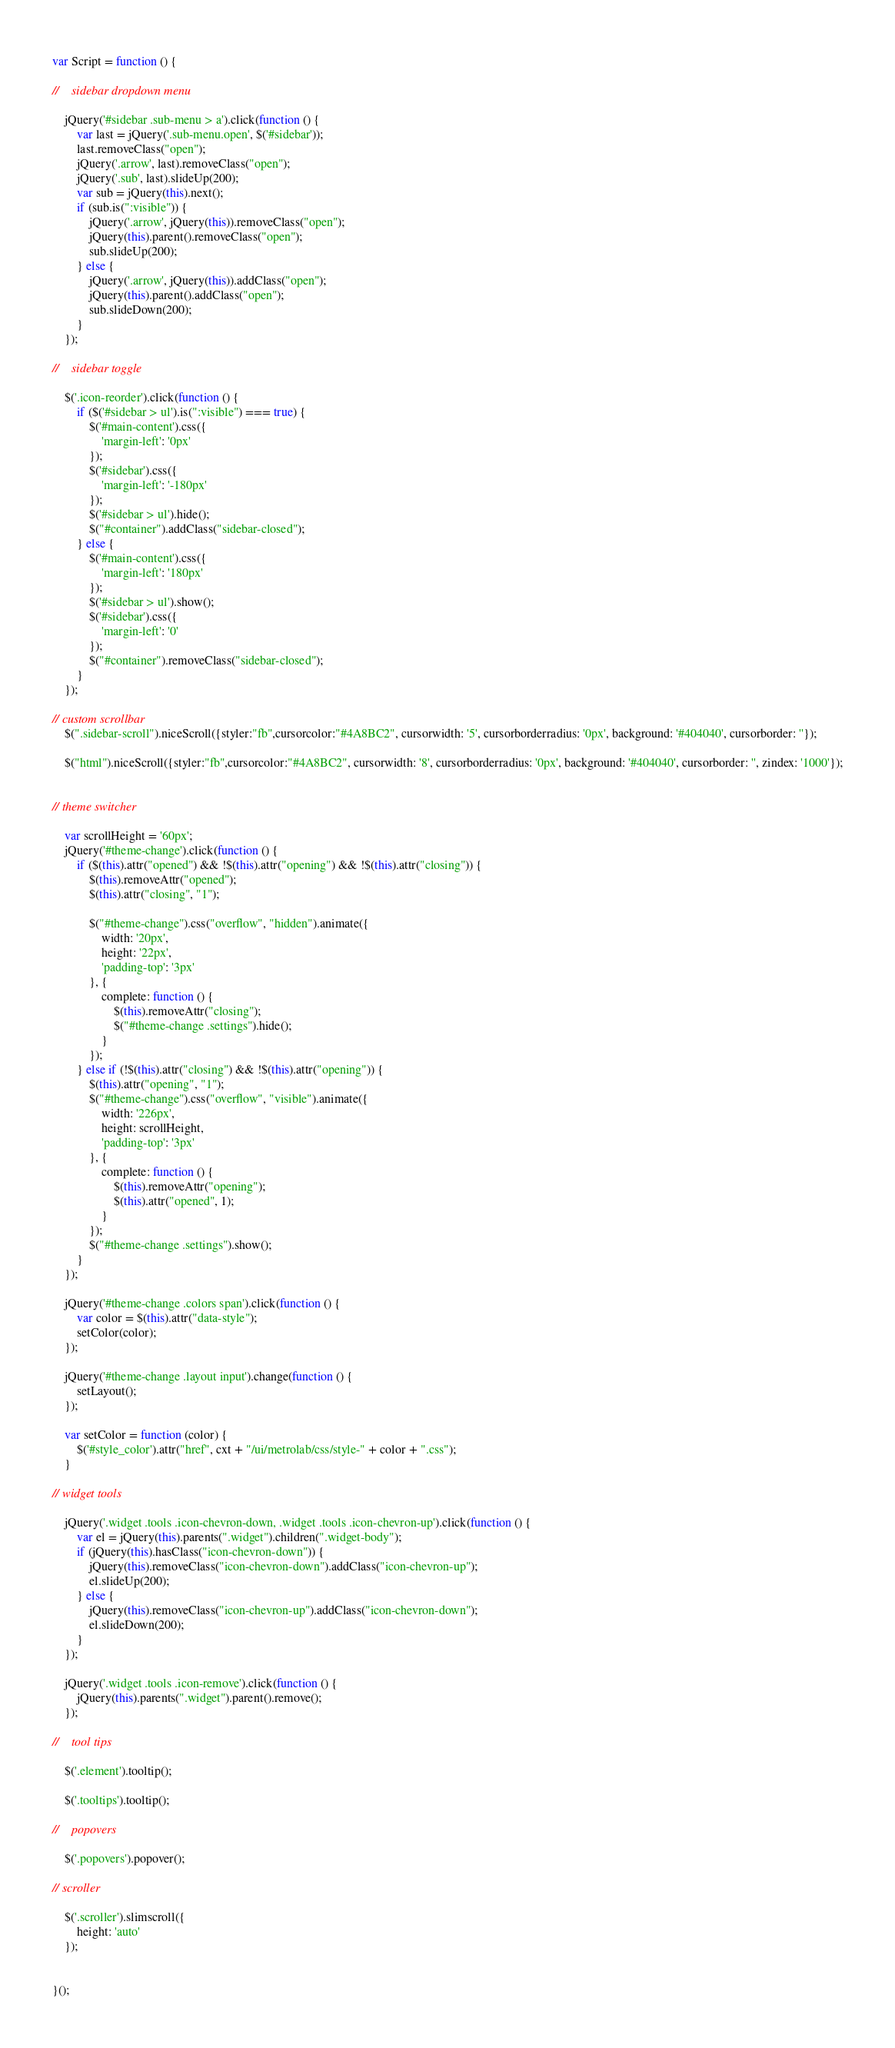<code> <loc_0><loc_0><loc_500><loc_500><_JavaScript_>var Script = function () {

//    sidebar dropdown menu

    jQuery('#sidebar .sub-menu > a').click(function () {
        var last = jQuery('.sub-menu.open', $('#sidebar'));
        last.removeClass("open");
        jQuery('.arrow', last).removeClass("open");
        jQuery('.sub', last).slideUp(200);
        var sub = jQuery(this).next();
        if (sub.is(":visible")) {
            jQuery('.arrow', jQuery(this)).removeClass("open");
            jQuery(this).parent().removeClass("open");
            sub.slideUp(200);
        } else {
            jQuery('.arrow', jQuery(this)).addClass("open");
            jQuery(this).parent().addClass("open");
            sub.slideDown(200);
        }
    });

//    sidebar toggle

    $('.icon-reorder').click(function () {
        if ($('#sidebar > ul').is(":visible") === true) {
            $('#main-content').css({
                'margin-left': '0px'
            });
            $('#sidebar').css({
                'margin-left': '-180px'
            });
            $('#sidebar > ul').hide();
            $("#container").addClass("sidebar-closed");
        } else {
            $('#main-content').css({
                'margin-left': '180px'
            });
            $('#sidebar > ul').show();
            $('#sidebar').css({
                'margin-left': '0'
            });
            $("#container").removeClass("sidebar-closed");
        }
    });

// custom scrollbar
    $(".sidebar-scroll").niceScroll({styler:"fb",cursorcolor:"#4A8BC2", cursorwidth: '5', cursorborderradius: '0px', background: '#404040', cursorborder: ''});

    $("html").niceScroll({styler:"fb",cursorcolor:"#4A8BC2", cursorwidth: '8', cursorborderradius: '0px', background: '#404040', cursorborder: '', zindex: '1000'});


// theme switcher

    var scrollHeight = '60px';
    jQuery('#theme-change').click(function () {
        if ($(this).attr("opened") && !$(this).attr("opening") && !$(this).attr("closing")) {
            $(this).removeAttr("opened");
            $(this).attr("closing", "1");

            $("#theme-change").css("overflow", "hidden").animate({
                width: '20px',
                height: '22px',
                'padding-top': '3px'
            }, {
                complete: function () {
                    $(this).removeAttr("closing");
                    $("#theme-change .settings").hide();
                }
            });
        } else if (!$(this).attr("closing") && !$(this).attr("opening")) {
            $(this).attr("opening", "1");
            $("#theme-change").css("overflow", "visible").animate({
                width: '226px',
                height: scrollHeight,
                'padding-top': '3px'
            }, {
                complete: function () {
                    $(this).removeAttr("opening");
                    $(this).attr("opened", 1);
                }
            });
            $("#theme-change .settings").show();
        }
    });

    jQuery('#theme-change .colors span').click(function () {
        var color = $(this).attr("data-style");
        setColor(color);
    });

    jQuery('#theme-change .layout input').change(function () {
        setLayout();
    });

    var setColor = function (color) {
        $('#style_color').attr("href", cxt + "/ui/metrolab/css/style-" + color + ".css");
    }

// widget tools

    jQuery('.widget .tools .icon-chevron-down, .widget .tools .icon-chevron-up').click(function () {
        var el = jQuery(this).parents(".widget").children(".widget-body");
        if (jQuery(this).hasClass("icon-chevron-down")) {
            jQuery(this).removeClass("icon-chevron-down").addClass("icon-chevron-up");
            el.slideUp(200);
        } else {
            jQuery(this).removeClass("icon-chevron-up").addClass("icon-chevron-down");
            el.slideDown(200);
        }
    });

    jQuery('.widget .tools .icon-remove').click(function () {
        jQuery(this).parents(".widget").parent().remove();
    });
    
//    tool tips

    $('.element').tooltip();

    $('.tooltips').tooltip();

//    popovers

    $('.popovers').popover();

// scroller

    $('.scroller').slimscroll({
        height: 'auto'
    });


}();</code> 